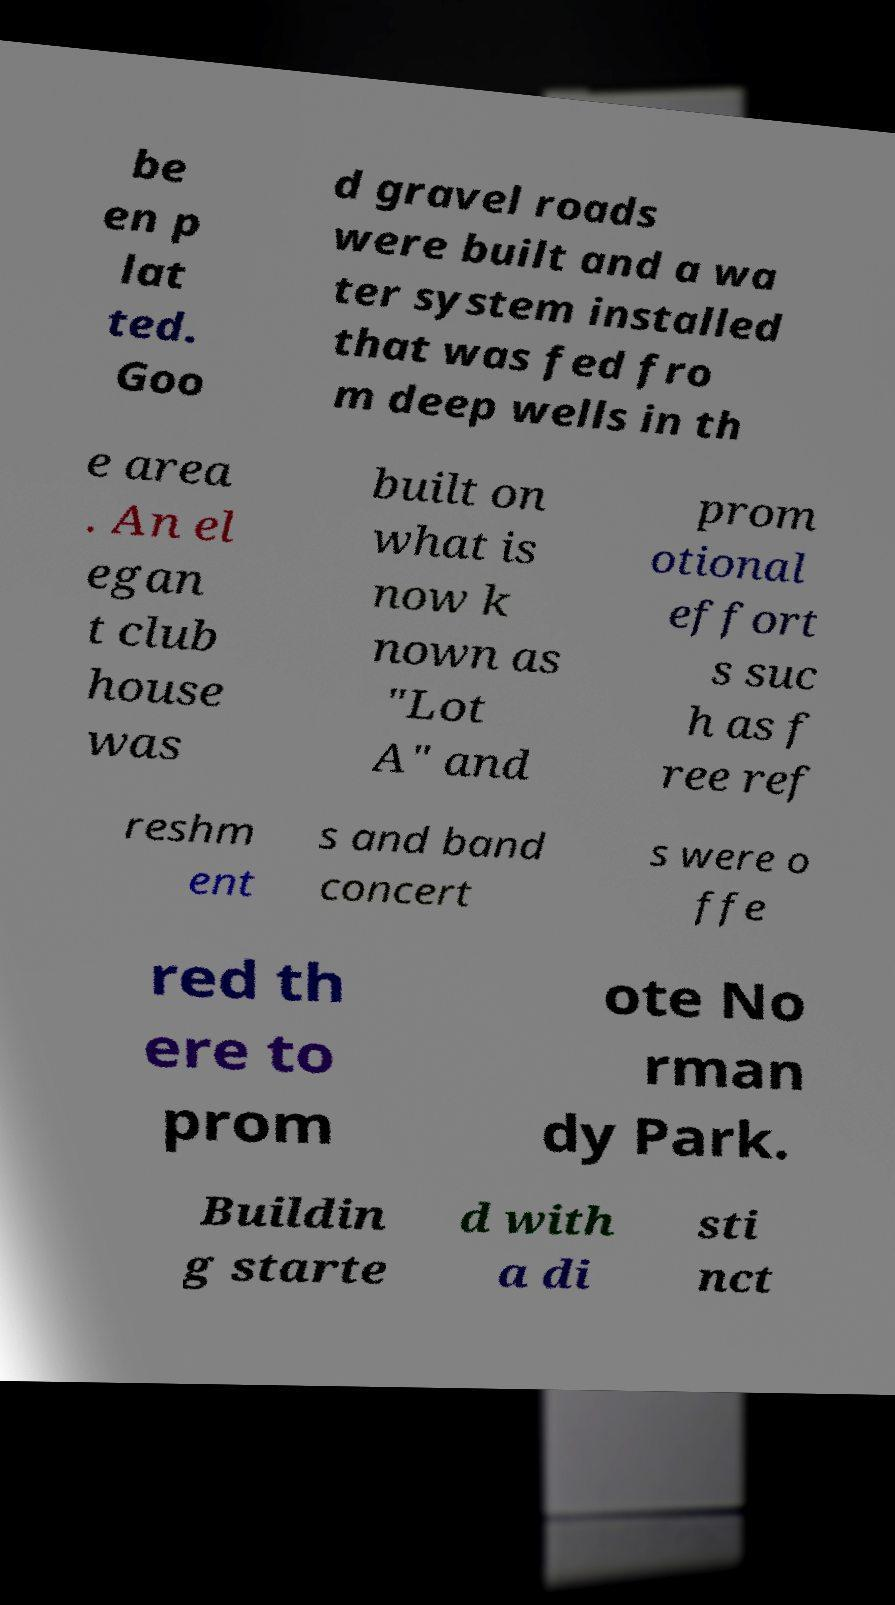Please identify and transcribe the text found in this image. be en p lat ted. Goo d gravel roads were built and a wa ter system installed that was fed fro m deep wells in th e area . An el egan t club house was built on what is now k nown as "Lot A" and prom otional effort s suc h as f ree ref reshm ent s and band concert s were o ffe red th ere to prom ote No rman dy Park. Buildin g starte d with a di sti nct 